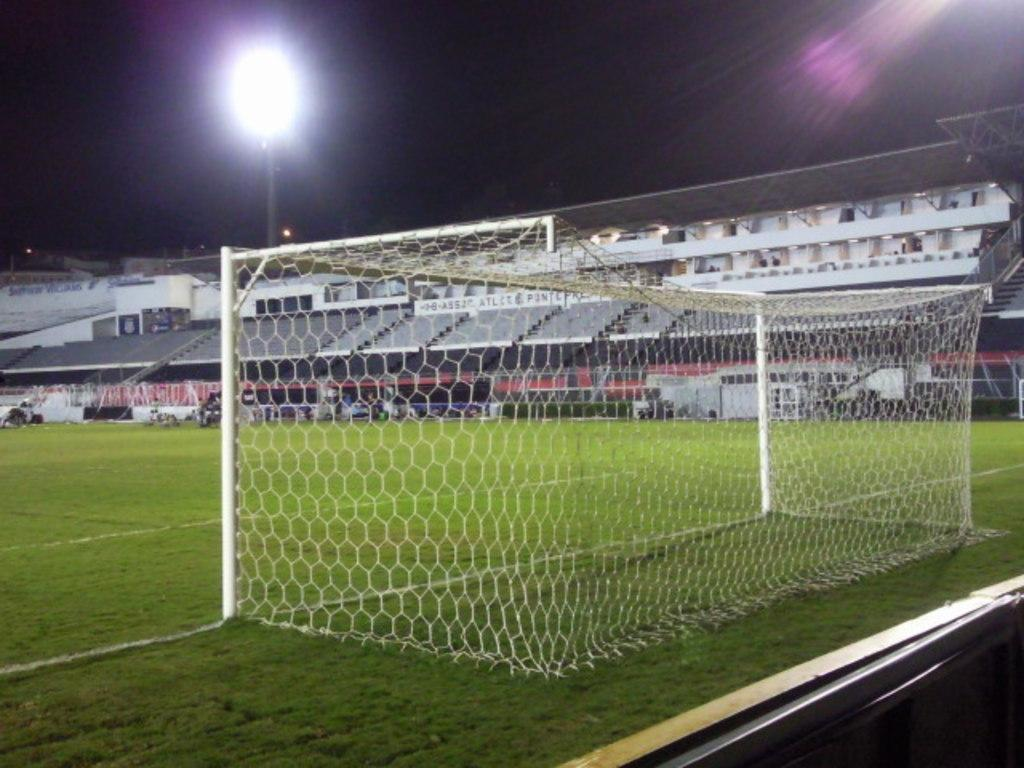What is the primary object in the image? There is a net in the image. What type of surface is visible in the image? There is grass in the image. Are there any seating options in the image? Yes, there are seats in the image. What is the purpose of the pole in the image? The pole is likely used to support the net or lights. What is illuminating the area in the image? There are lights in the image. How would you describe the overall lighting in the image? The background of the image is dark. What type of ink is being used to write on the quiver in the image? There is no quiver or writing present in the image. 